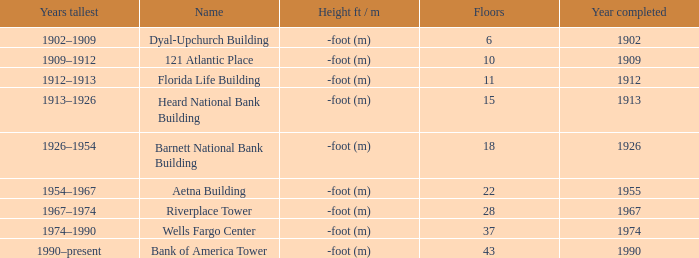What year was the building completed that has 10 floors? 1909.0. 